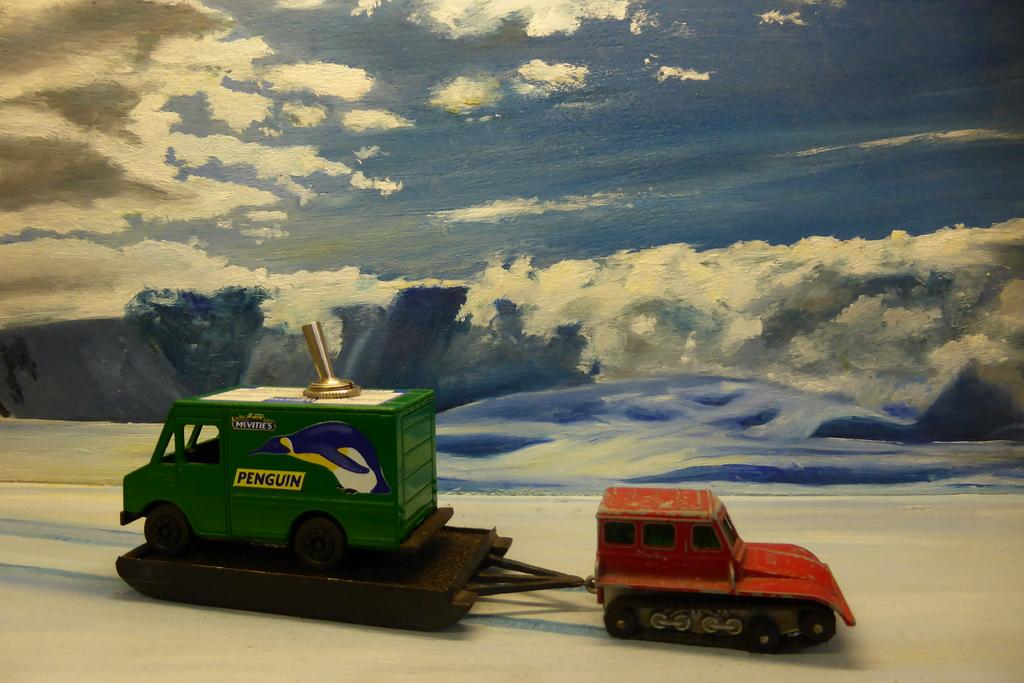How many toys are visible in the image? There are 2 toys in the image. Where are the toys placed in relation to the painting? The toys are kept in front of a painting. What is the subject matter of the painting? The painting depicts a blue sky and mountains. Can you tell me how many keys are hanging on the border of the painting? There are no keys present in the image, and no mention of a border on the painting. 